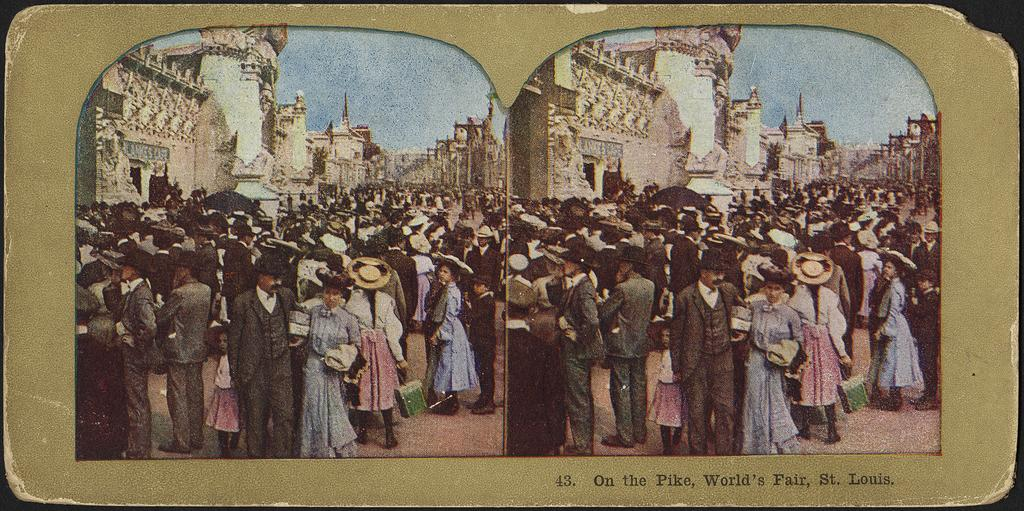<image>
Share a concise interpretation of the image provided. Two side by side images of a crowd in the street at the World's Fair in St. Louis. 